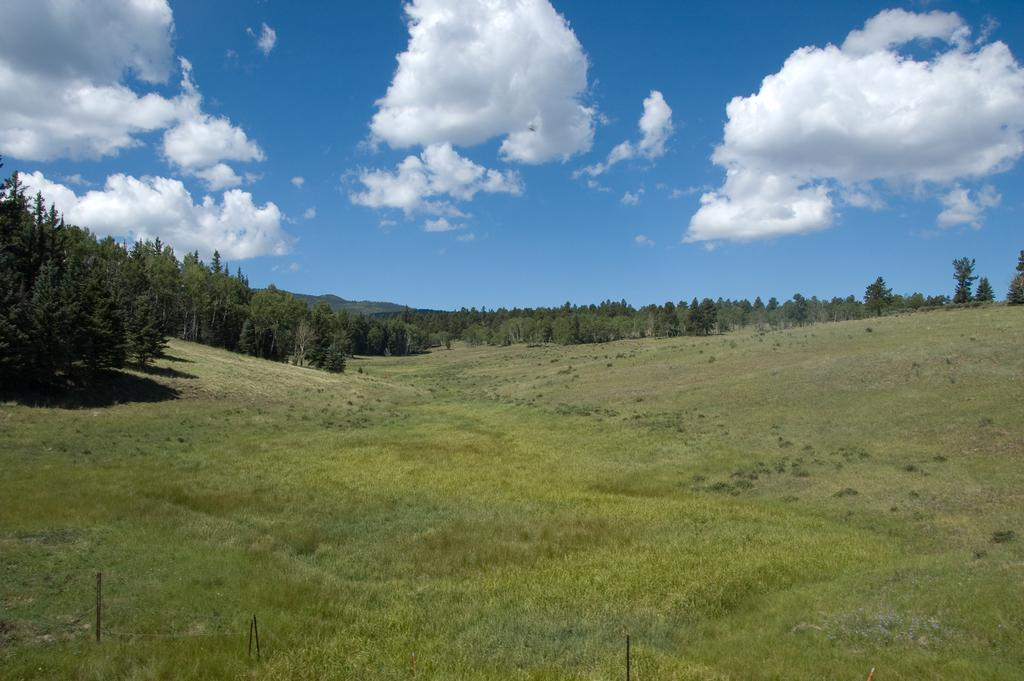What type of vegetation is on the ground in the image? There is grass on the ground in the image. What can be seen in the background of the image? There are trees in the background of the image. What is visible at the top of the image? The sky is visible at the top of the image. What is present in the sky? Clouds are present in the sky. What type of wax can be seen melting on the book in the image? There is no wax or book present in the image; it features grass, trees, and a sky with clouds. How does the grass in the image affect the hearing of the people nearby? The grass in the image does not affect the hearing of any people, as it is an inanimate object and not capable of influencing auditory perception. 